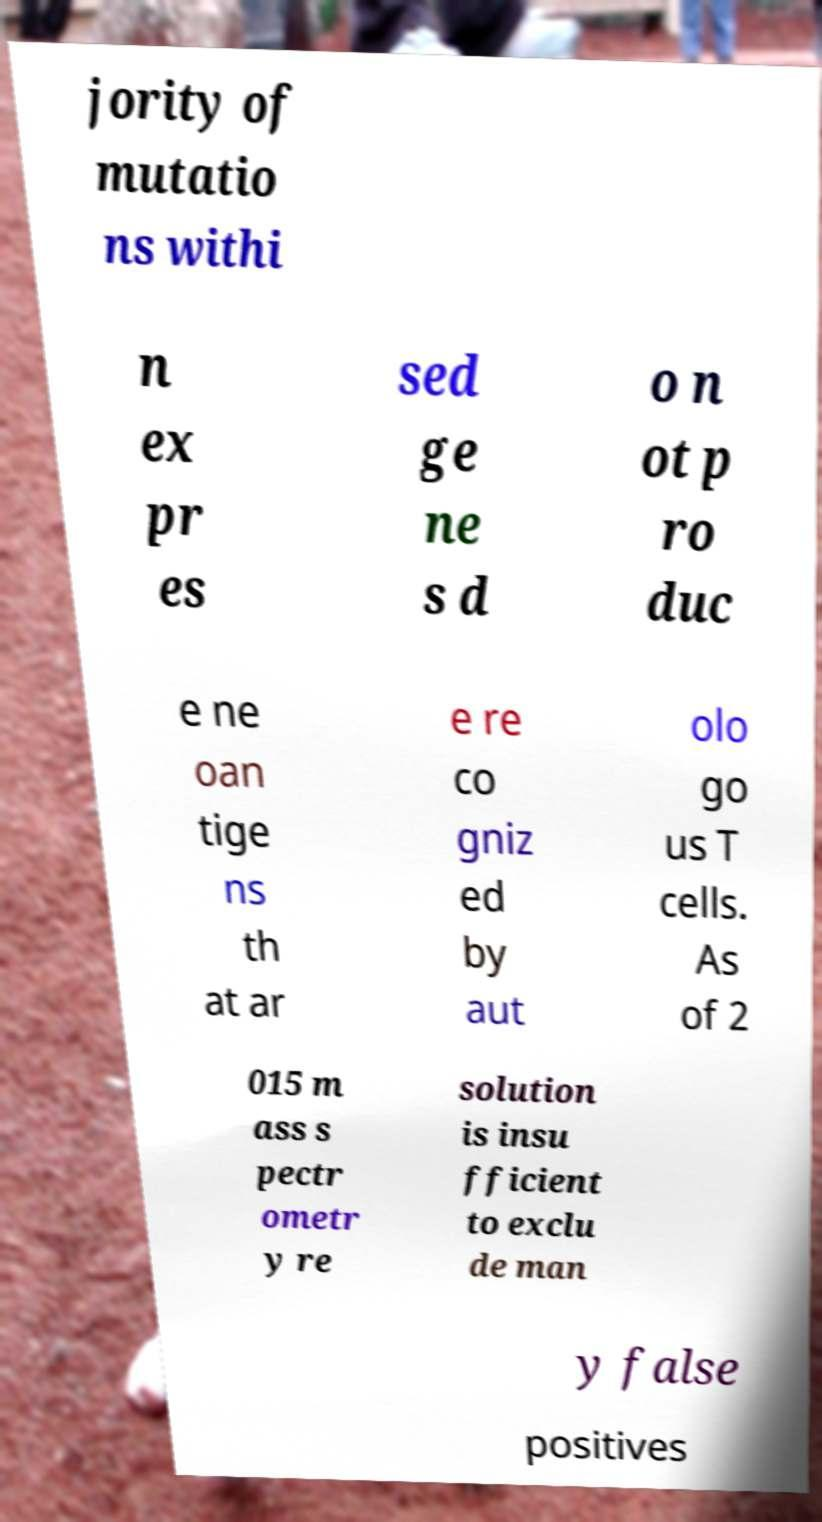Could you assist in decoding the text presented in this image and type it out clearly? jority of mutatio ns withi n ex pr es sed ge ne s d o n ot p ro duc e ne oan tige ns th at ar e re co gniz ed by aut olo go us T cells. As of 2 015 m ass s pectr ometr y re solution is insu fficient to exclu de man y false positives 